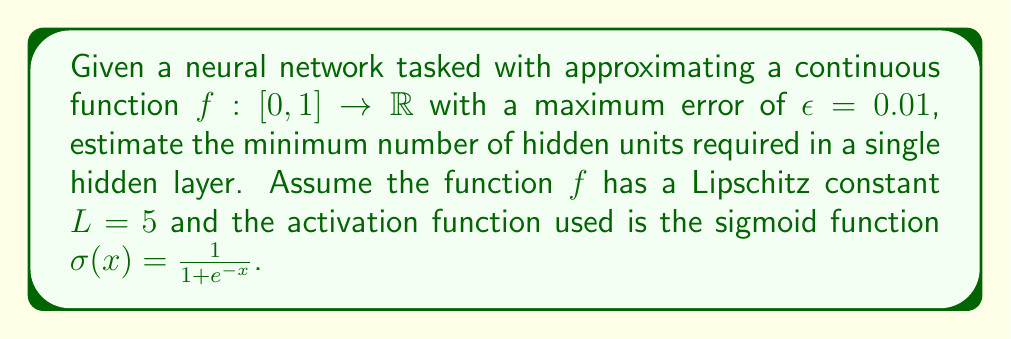What is the answer to this math problem? To estimate the minimum number of hidden units, we can use the universal approximation theorem and its extensions. The process involves these steps:

1) The universal approximation theorem states that a feedforward network with a single hidden layer containing a finite number of neurons can approximate continuous functions on compact subsets of $\mathbb{R}^n$.

2) Barron's theorem provides a more precise bound on the number of hidden units needed. For a function with bounded first moment of the magnitude distribution of the Fourier transform, the approximation error is $O(\frac{1}{\sqrt{n}})$, where $n$ is the number of hidden units.

3) For our specific case with a Lipschitz continuous function, we can use a result by Yarotsky (2017) which states that for a function $f$ with Lipschitz constant $L$ on $[0,1]$, the number of hidden units $n$ required to achieve an approximation error $\epsilon$ is:

   $$n = O\left(\left(\frac{L}{\epsilon}\right)^d \log\left(\frac{L}{\epsilon}\right)\right)$$

   where $d$ is the input dimension (in this case, $d=1$).

4) Substituting our values:
   $L = 5$, $\epsilon = 0.01$, $d = 1$

   $$n = O\left(\left(\frac{5}{0.01}\right)^1 \log\left(\frac{5}{0.01}\right)\right)$$
   $$n = O(500 \log(500))$$
   $$n \approx O(3107)$$

5) The big O notation gives us the order of magnitude. In practice, we often need to use a constant factor to get a more precise estimate. A common factor is about 2-3 times the big O estimate.

Therefore, a reasonable estimate for the minimum number of hidden units would be around 6000-9000.
Answer: The estimated minimum number of hidden units required is approximately 6000-9000. 